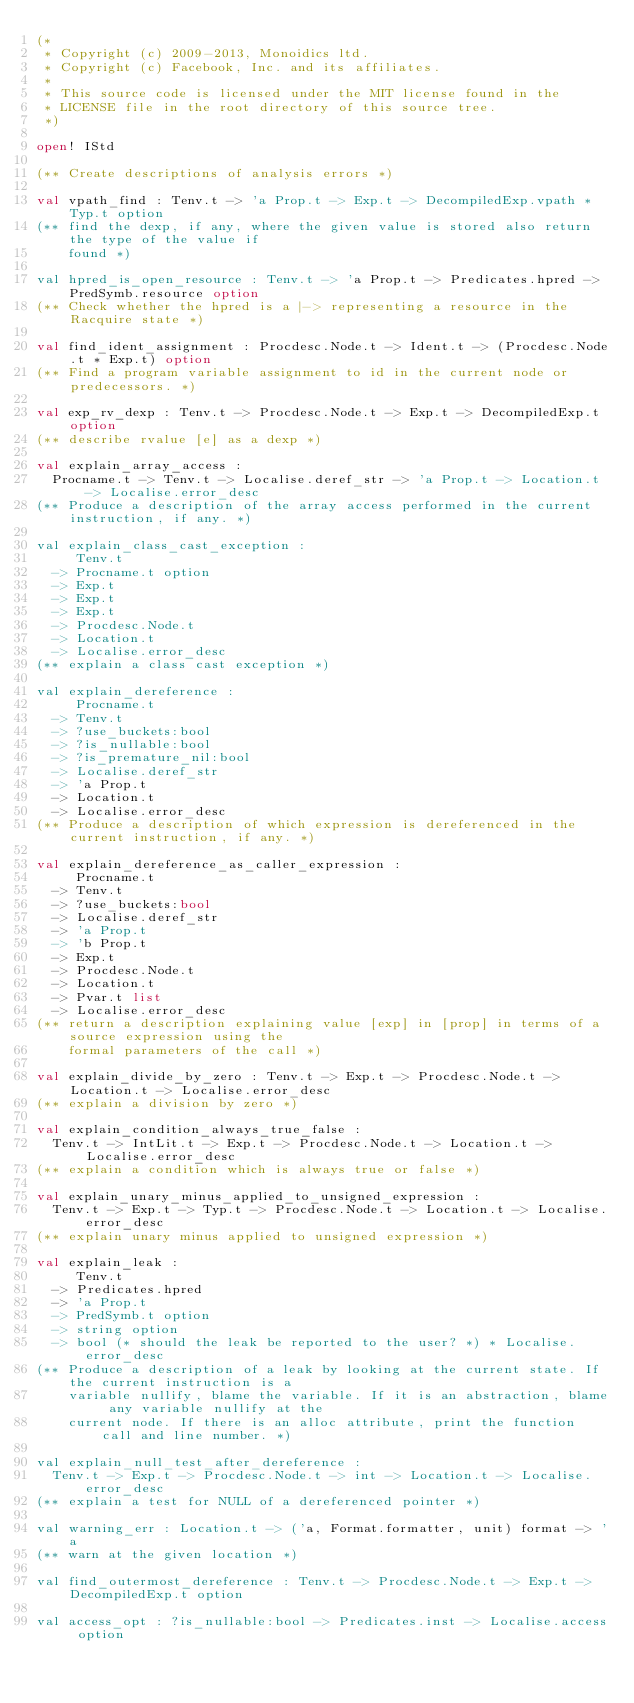Convert code to text. <code><loc_0><loc_0><loc_500><loc_500><_OCaml_>(*
 * Copyright (c) 2009-2013, Monoidics ltd.
 * Copyright (c) Facebook, Inc. and its affiliates.
 *
 * This source code is licensed under the MIT license found in the
 * LICENSE file in the root directory of this source tree.
 *)

open! IStd

(** Create descriptions of analysis errors *)

val vpath_find : Tenv.t -> 'a Prop.t -> Exp.t -> DecompiledExp.vpath * Typ.t option
(** find the dexp, if any, where the given value is stored also return the type of the value if
    found *)

val hpred_is_open_resource : Tenv.t -> 'a Prop.t -> Predicates.hpred -> PredSymb.resource option
(** Check whether the hpred is a |-> representing a resource in the Racquire state *)

val find_ident_assignment : Procdesc.Node.t -> Ident.t -> (Procdesc.Node.t * Exp.t) option
(** Find a program variable assignment to id in the current node or predecessors. *)

val exp_rv_dexp : Tenv.t -> Procdesc.Node.t -> Exp.t -> DecompiledExp.t option
(** describe rvalue [e] as a dexp *)

val explain_array_access :
  Procname.t -> Tenv.t -> Localise.deref_str -> 'a Prop.t -> Location.t -> Localise.error_desc
(** Produce a description of the array access performed in the current instruction, if any. *)

val explain_class_cast_exception :
     Tenv.t
  -> Procname.t option
  -> Exp.t
  -> Exp.t
  -> Exp.t
  -> Procdesc.Node.t
  -> Location.t
  -> Localise.error_desc
(** explain a class cast exception *)

val explain_dereference :
     Procname.t
  -> Tenv.t
  -> ?use_buckets:bool
  -> ?is_nullable:bool
  -> ?is_premature_nil:bool
  -> Localise.deref_str
  -> 'a Prop.t
  -> Location.t
  -> Localise.error_desc
(** Produce a description of which expression is dereferenced in the current instruction, if any. *)

val explain_dereference_as_caller_expression :
     Procname.t
  -> Tenv.t
  -> ?use_buckets:bool
  -> Localise.deref_str
  -> 'a Prop.t
  -> 'b Prop.t
  -> Exp.t
  -> Procdesc.Node.t
  -> Location.t
  -> Pvar.t list
  -> Localise.error_desc
(** return a description explaining value [exp] in [prop] in terms of a source expression using the
    formal parameters of the call *)

val explain_divide_by_zero : Tenv.t -> Exp.t -> Procdesc.Node.t -> Location.t -> Localise.error_desc
(** explain a division by zero *)

val explain_condition_always_true_false :
  Tenv.t -> IntLit.t -> Exp.t -> Procdesc.Node.t -> Location.t -> Localise.error_desc
(** explain a condition which is always true or false *)

val explain_unary_minus_applied_to_unsigned_expression :
  Tenv.t -> Exp.t -> Typ.t -> Procdesc.Node.t -> Location.t -> Localise.error_desc
(** explain unary minus applied to unsigned expression *)

val explain_leak :
     Tenv.t
  -> Predicates.hpred
  -> 'a Prop.t
  -> PredSymb.t option
  -> string option
  -> bool (* should the leak be reported to the user? *) * Localise.error_desc
(** Produce a description of a leak by looking at the current state. If the current instruction is a
    variable nullify, blame the variable. If it is an abstraction, blame any variable nullify at the
    current node. If there is an alloc attribute, print the function call and line number. *)

val explain_null_test_after_dereference :
  Tenv.t -> Exp.t -> Procdesc.Node.t -> int -> Location.t -> Localise.error_desc
(** explain a test for NULL of a dereferenced pointer *)

val warning_err : Location.t -> ('a, Format.formatter, unit) format -> 'a
(** warn at the given location *)

val find_outermost_dereference : Tenv.t -> Procdesc.Node.t -> Exp.t -> DecompiledExp.t option

val access_opt : ?is_nullable:bool -> Predicates.inst -> Localise.access option
</code> 